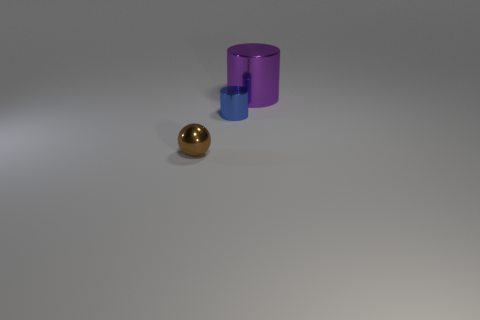Add 2 big yellow cylinders. How many objects exist? 5 Subtract all spheres. How many objects are left? 2 Add 3 purple things. How many purple things exist? 4 Subtract 0 blue blocks. How many objects are left? 3 Subtract all small metallic cylinders. Subtract all tiny objects. How many objects are left? 0 Add 2 tiny cylinders. How many tiny cylinders are left? 3 